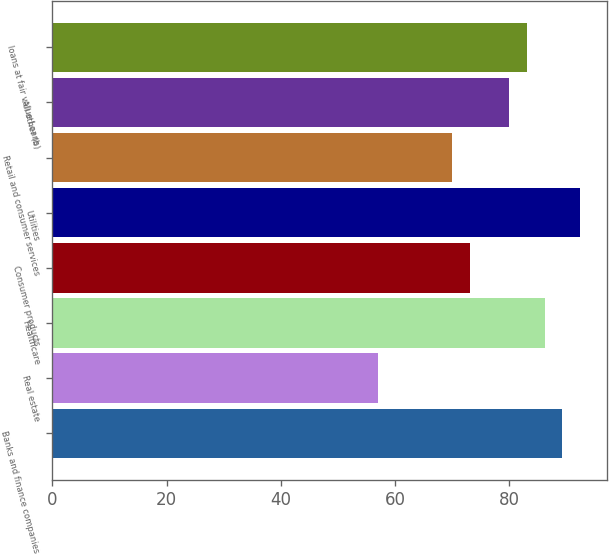Convert chart to OTSL. <chart><loc_0><loc_0><loc_500><loc_500><bar_chart><fcel>Banks and finance companies<fcel>Real estate<fcel>Healthcare<fcel>Consumer products<fcel>Utilities<fcel>Retail and consumer services<fcel>All other (b)<fcel>loans at fair value Loans<nl><fcel>89.3<fcel>57<fcel>86.2<fcel>73.1<fcel>92.4<fcel>70<fcel>80<fcel>83.1<nl></chart> 